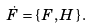<formula> <loc_0><loc_0><loc_500><loc_500>\dot { F } = \{ \, F , H \, \} \, .</formula> 